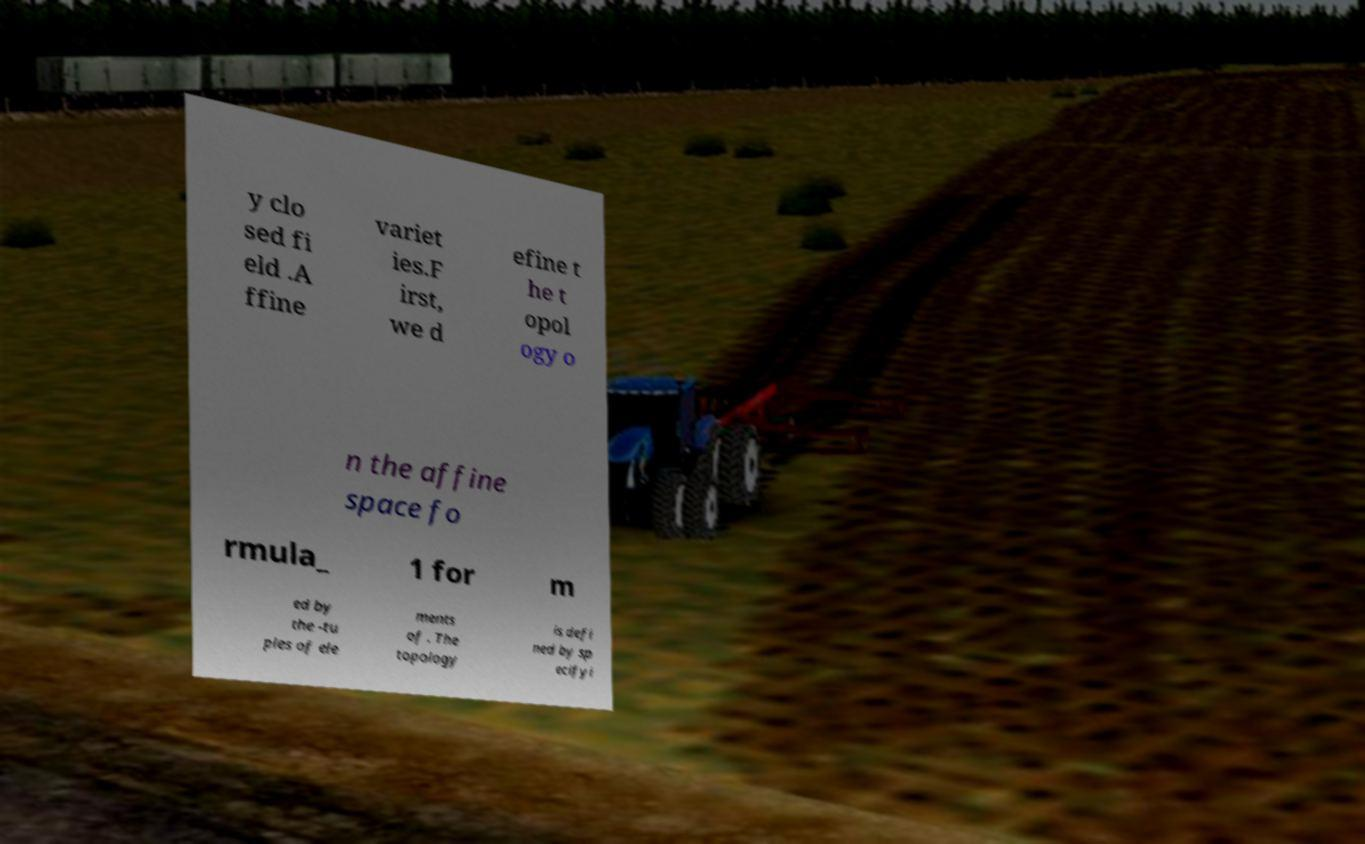There's text embedded in this image that I need extracted. Can you transcribe it verbatim? y clo sed fi eld .A ffine variet ies.F irst, we d efine t he t opol ogy o n the affine space fo rmula_ 1 for m ed by the -tu ples of ele ments of . The topology is defi ned by sp ecifyi 